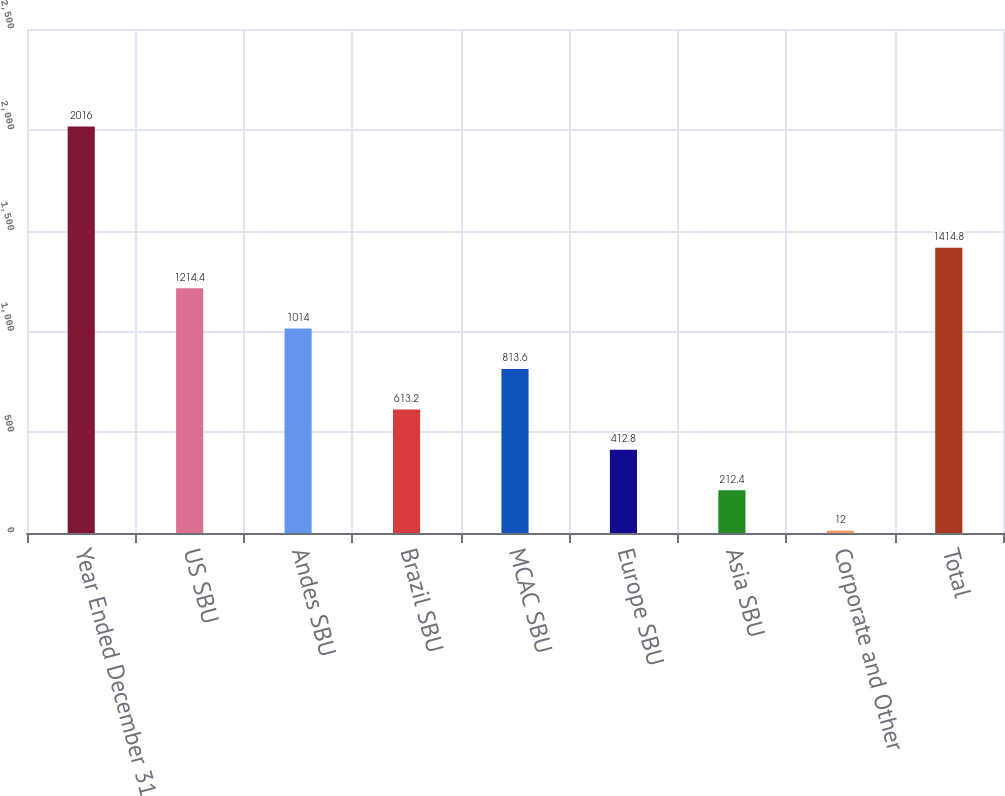Convert chart. <chart><loc_0><loc_0><loc_500><loc_500><bar_chart><fcel>Year Ended December 31<fcel>US SBU<fcel>Andes SBU<fcel>Brazil SBU<fcel>MCAC SBU<fcel>Europe SBU<fcel>Asia SBU<fcel>Corporate and Other<fcel>Total<nl><fcel>2016<fcel>1214.4<fcel>1014<fcel>613.2<fcel>813.6<fcel>412.8<fcel>212.4<fcel>12<fcel>1414.8<nl></chart> 